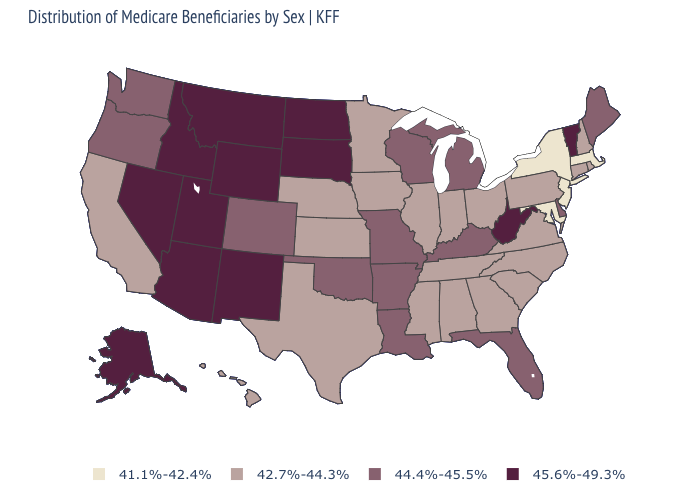Does Oregon have a higher value than Florida?
Write a very short answer. No. What is the highest value in states that border Idaho?
Answer briefly. 45.6%-49.3%. What is the value of Massachusetts?
Answer briefly. 41.1%-42.4%. Among the states that border Ohio , which have the highest value?
Quick response, please. West Virginia. Does Idaho have a lower value than Arkansas?
Write a very short answer. No. Which states hav the highest value in the West?
Keep it brief. Alaska, Arizona, Idaho, Montana, Nevada, New Mexico, Utah, Wyoming. What is the value of Arizona?
Write a very short answer. 45.6%-49.3%. Name the states that have a value in the range 41.1%-42.4%?
Keep it brief. Maryland, Massachusetts, New Jersey, New York. Name the states that have a value in the range 42.7%-44.3%?
Short answer required. Alabama, California, Connecticut, Georgia, Hawaii, Illinois, Indiana, Iowa, Kansas, Minnesota, Mississippi, Nebraska, New Hampshire, North Carolina, Ohio, Pennsylvania, Rhode Island, South Carolina, Tennessee, Texas, Virginia. What is the value of Missouri?
Answer briefly. 44.4%-45.5%. Which states have the lowest value in the West?
Write a very short answer. California, Hawaii. What is the lowest value in the USA?
Write a very short answer. 41.1%-42.4%. Name the states that have a value in the range 41.1%-42.4%?
Keep it brief. Maryland, Massachusetts, New Jersey, New York. Does California have the lowest value in the USA?
Be succinct. No. Name the states that have a value in the range 41.1%-42.4%?
Concise answer only. Maryland, Massachusetts, New Jersey, New York. 